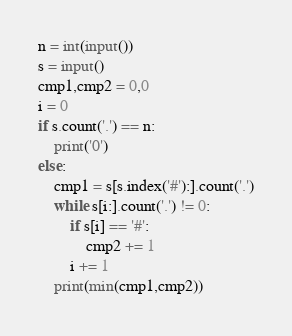<code> <loc_0><loc_0><loc_500><loc_500><_Python_>n = int(input())
s = input()
cmp1,cmp2 = 0,0
i = 0
if s.count('.') == n:
    print('0')
else:
    cmp1 = s[s.index('#'):].count('.')
    while s[i:].count('.') != 0:
        if s[i] == '#':
            cmp2 += 1
        i += 1
    print(min(cmp1,cmp2))
</code> 